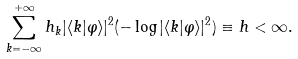Convert formula to latex. <formula><loc_0><loc_0><loc_500><loc_500>\sum _ { k = - \infty } ^ { + \infty } h _ { k } | \langle k | \varphi \rangle | ^ { 2 } ( - \log | \langle k | \varphi \rangle | ^ { 2 } ) \equiv h < \infty .</formula> 